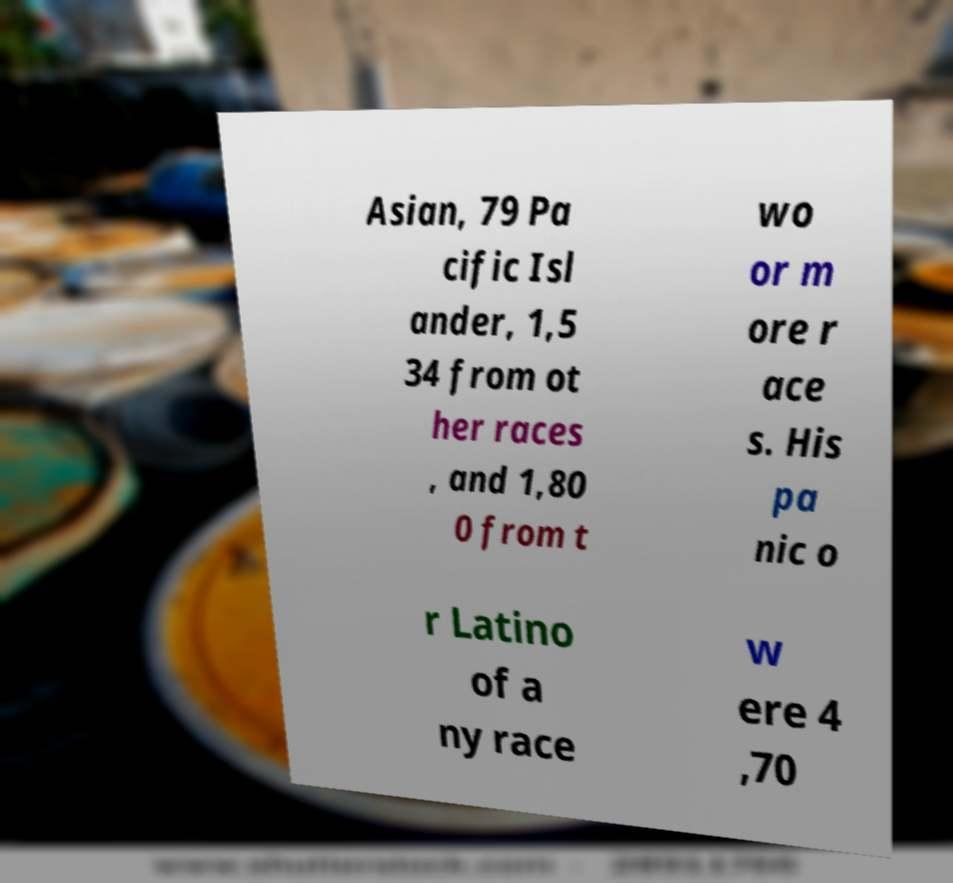What messages or text are displayed in this image? I need them in a readable, typed format. Asian, 79 Pa cific Isl ander, 1,5 34 from ot her races , and 1,80 0 from t wo or m ore r ace s. His pa nic o r Latino of a ny race w ere 4 ,70 